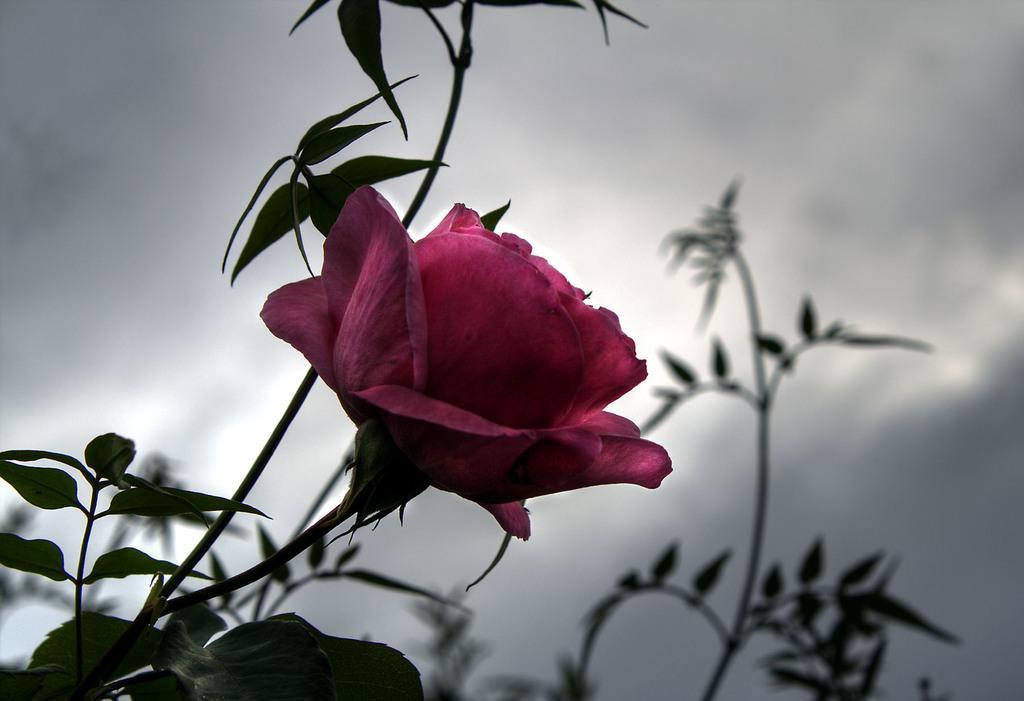Can you describe this image briefly? In this image I can see a flower and number of leaves in the front. In the background I can see few plants, clouds and the sky. 